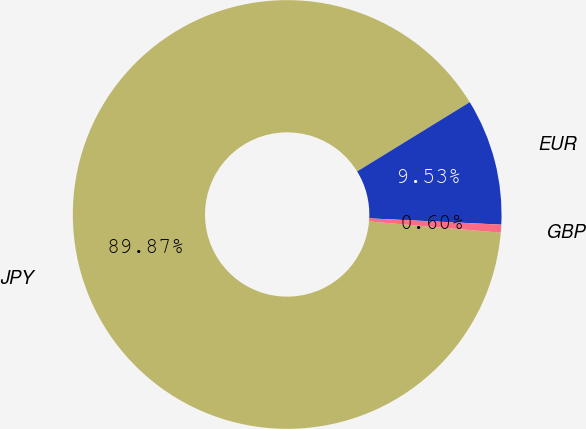Convert chart. <chart><loc_0><loc_0><loc_500><loc_500><pie_chart><fcel>JPY<fcel>EUR<fcel>GBP<nl><fcel>89.87%<fcel>9.53%<fcel>0.6%<nl></chart> 